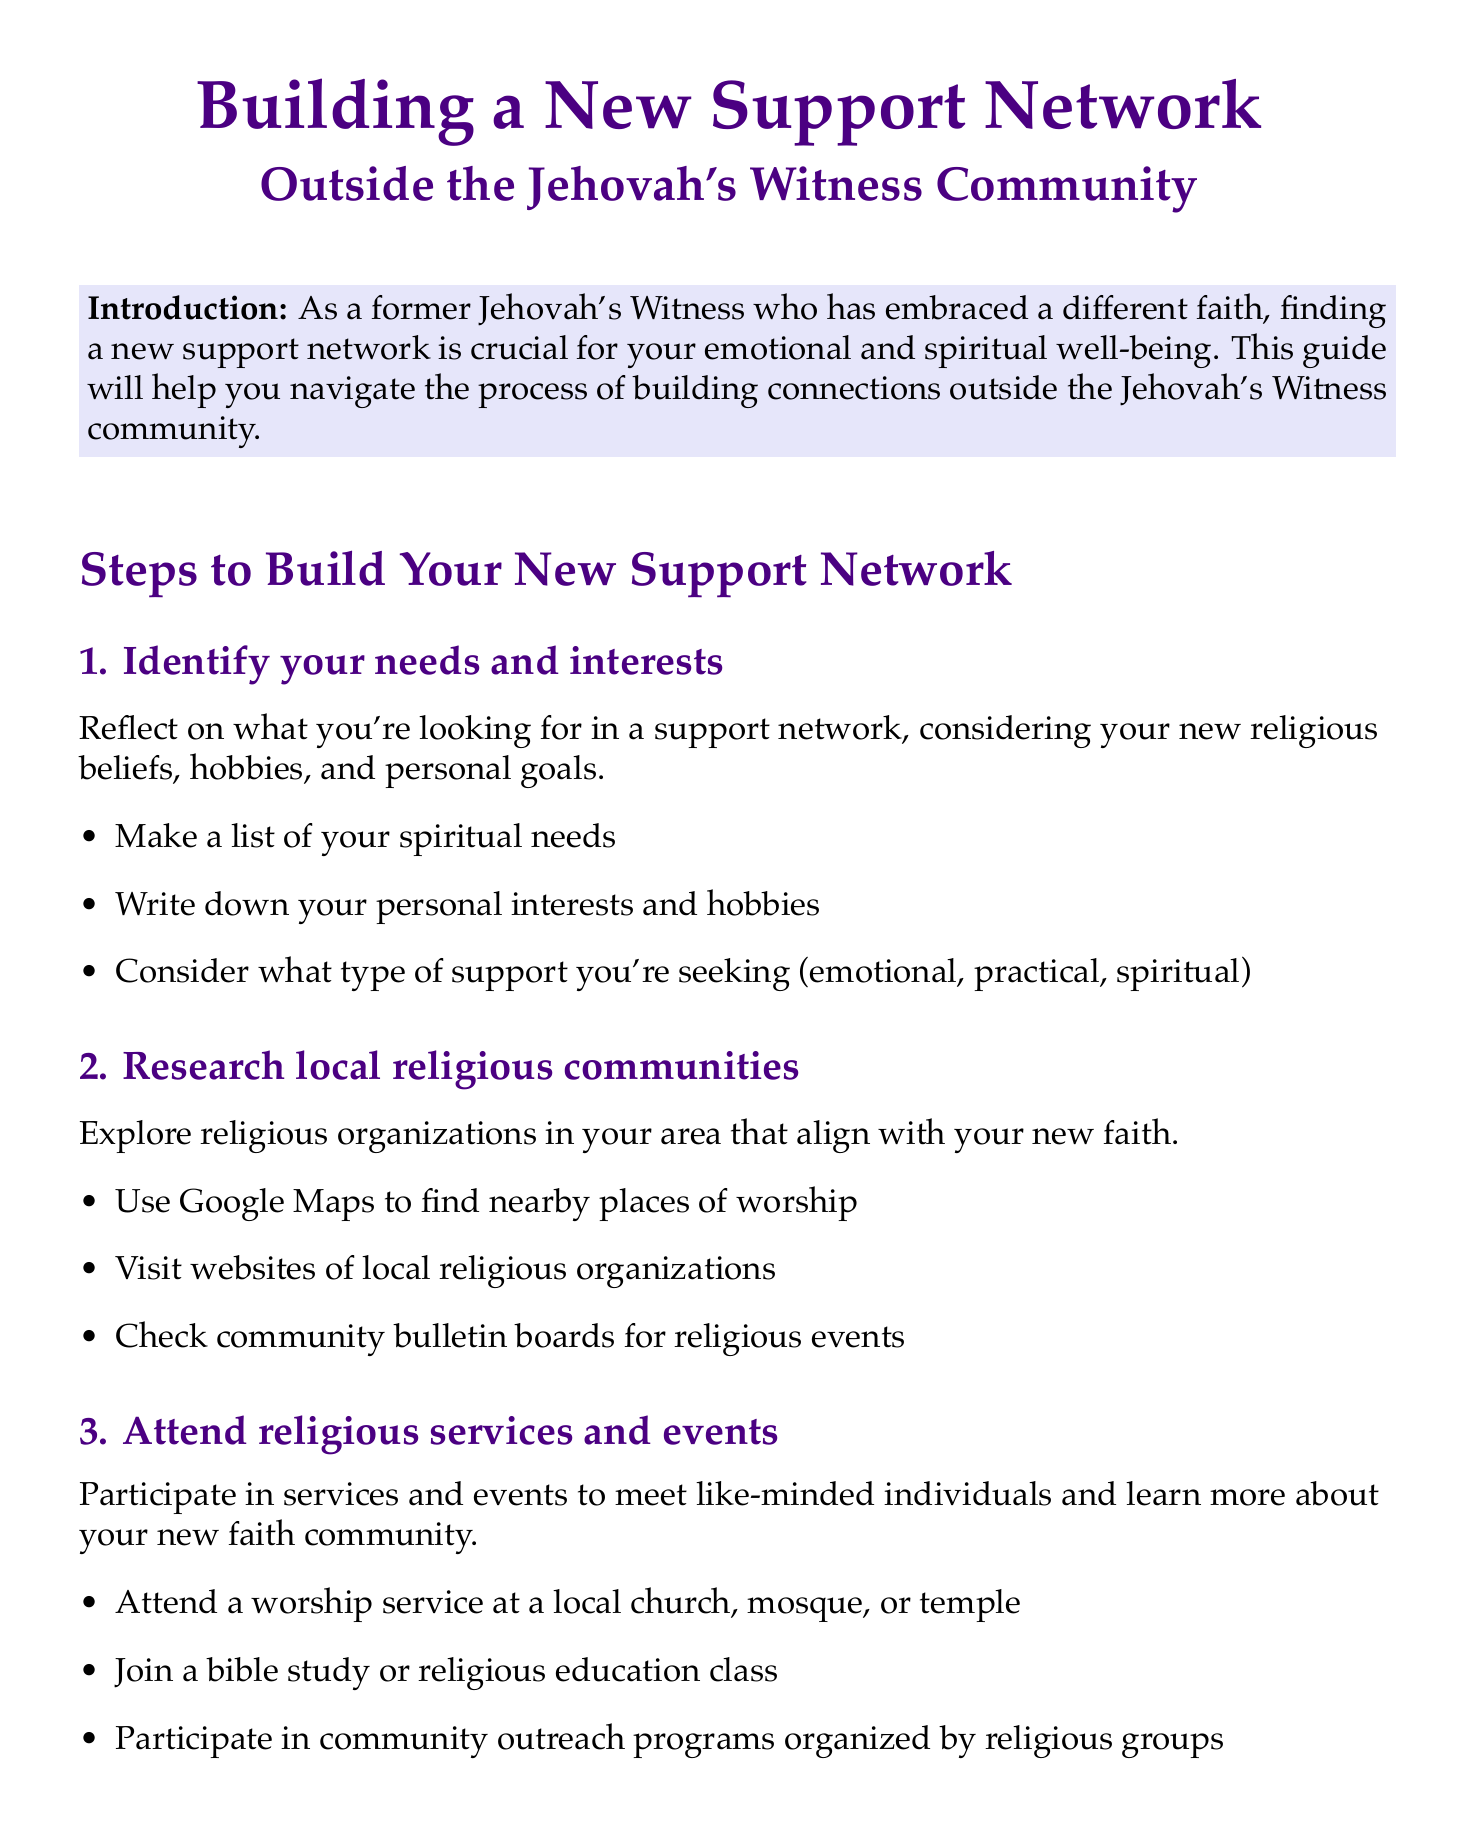What is the title of the document? The title clearly states the main focus of the manual, which is about building a support network outside of a specific community.
Answer: Building a New Support Network Outside the Jehovah's Witness Community How many steps are included in the guide? The document lists a specific number of steps to follow in order to build a new support network.
Answer: 10 What is the first step to build a support network? The document outlines the steps in order, with each step having a specific focus for building connections.
Answer: Identify your needs and interests Which online resource is suggested for connecting with others who have left the Jehovah's Witness faith? The document provides examples of online platforms where people can seek support and connect with others.
Answer: Facebook groups like 'Ex-Jehovah's Witnesses Support Group' What should you do to reconnect with family and friends? The document suggests specific action items to take in order to rebuild connections with people who may have had similar experiences.
Answer: Send a heartfelt message explaining your situation What type of support should you consider seeking according to the first step? The document indicates different forms of support that might be relevant for someone looking to build a support network.
Answer: Emotional, practical, spiritual Which step involves volunteering in the community? The document refers to a specific step dedicated to community engagement as a way to meet new people.
Answer: 7 What is the conclusion of the guide? The conclusion summarizes the overarching theme and encouragement provided throughout the document.
Answer: Building a new support network is a journey What should you do if you want to find local chapters for support groups? The document explains steps related to attending specific support groups for those transitioning away from certain faiths.
Answer: Search for local chapters of Recovering from Religion 